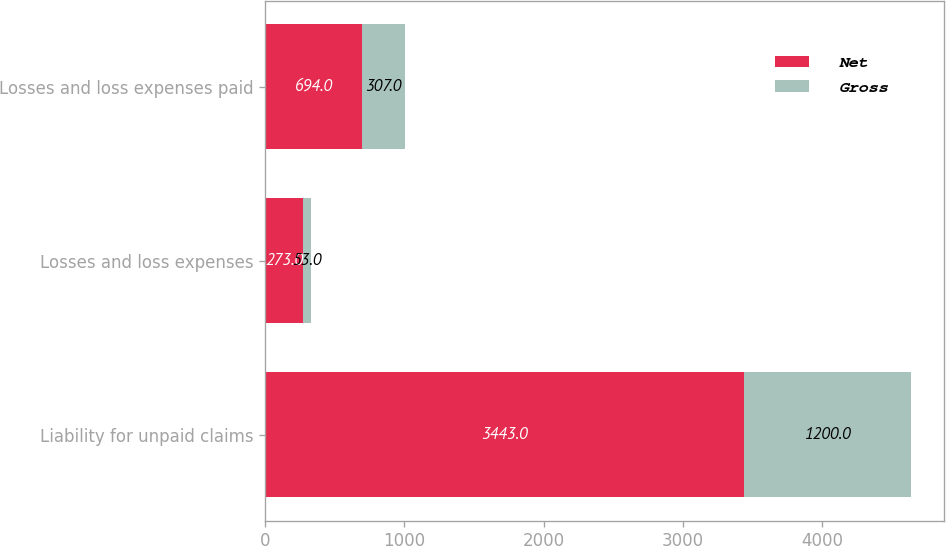<chart> <loc_0><loc_0><loc_500><loc_500><stacked_bar_chart><ecel><fcel>Liability for unpaid claims<fcel>Losses and loss expenses<fcel>Losses and loss expenses paid<nl><fcel>Net<fcel>3443<fcel>273<fcel>694<nl><fcel>Gross<fcel>1200<fcel>53<fcel>307<nl></chart> 